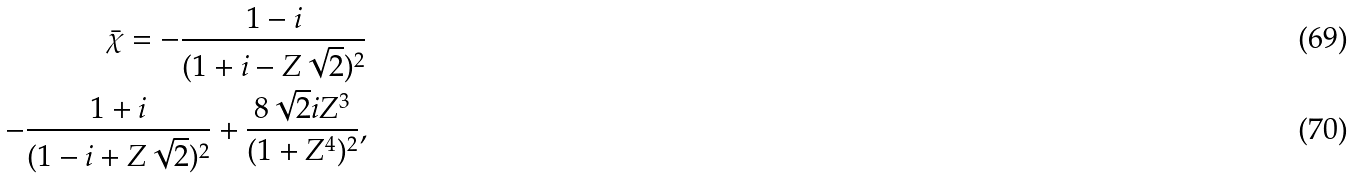<formula> <loc_0><loc_0><loc_500><loc_500>\bar { \chi } = - \frac { 1 - i } { ( 1 + i - Z \sqrt { 2 } ) ^ { 2 } } \\ - \frac { 1 + i } { ( 1 - i + Z \sqrt { 2 } ) ^ { 2 } } + \frac { 8 \sqrt { 2 } i Z ^ { 3 } } { ( 1 + Z ^ { 4 } ) ^ { 2 } } ,</formula> 